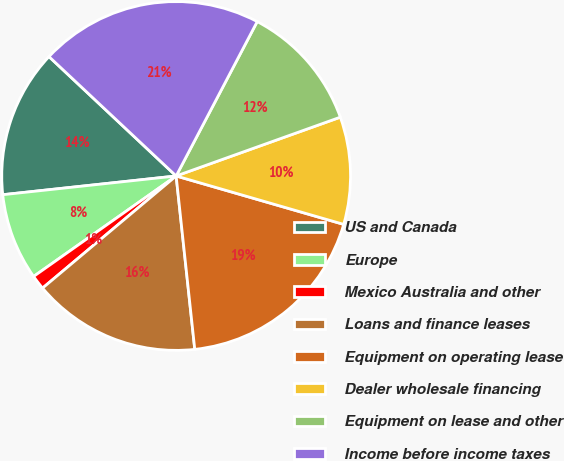Convert chart to OTSL. <chart><loc_0><loc_0><loc_500><loc_500><pie_chart><fcel>US and Canada<fcel>Europe<fcel>Mexico Australia and other<fcel>Loans and finance leases<fcel>Equipment on operating lease<fcel>Dealer wholesale financing<fcel>Equipment on lease and other<fcel>Income before income taxes<nl><fcel>13.71%<fcel>8.06%<fcel>1.34%<fcel>15.59%<fcel>18.82%<fcel>9.95%<fcel>11.83%<fcel>20.7%<nl></chart> 